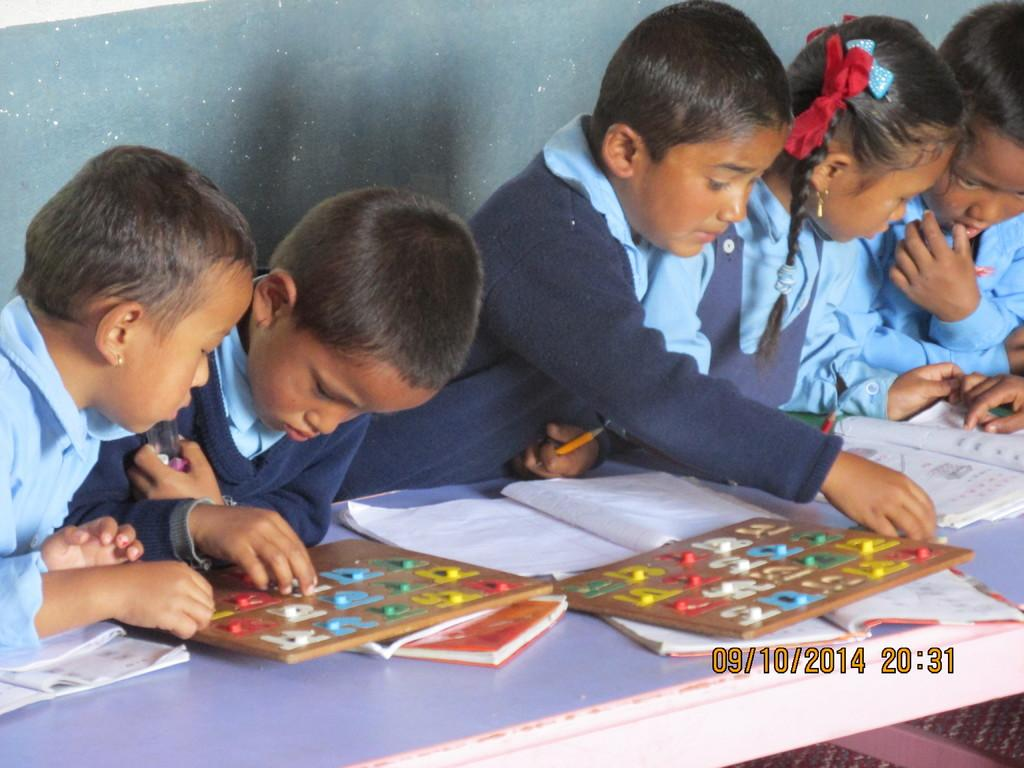How many people are in the image? There is a group of people in the image, but the exact number is not specified. Where are the people located in relation to the table? The group of people is behind a table. What items can be seen on the table? There are books and other objects on the table. What is at the bottom of the image? There is a mat at the bottom of the image. What is at the back of the image? There is a wall at the back of the image. How many eggs are on the table in the image? There is no mention of eggs in the image; only books and other objects are mentioned. 